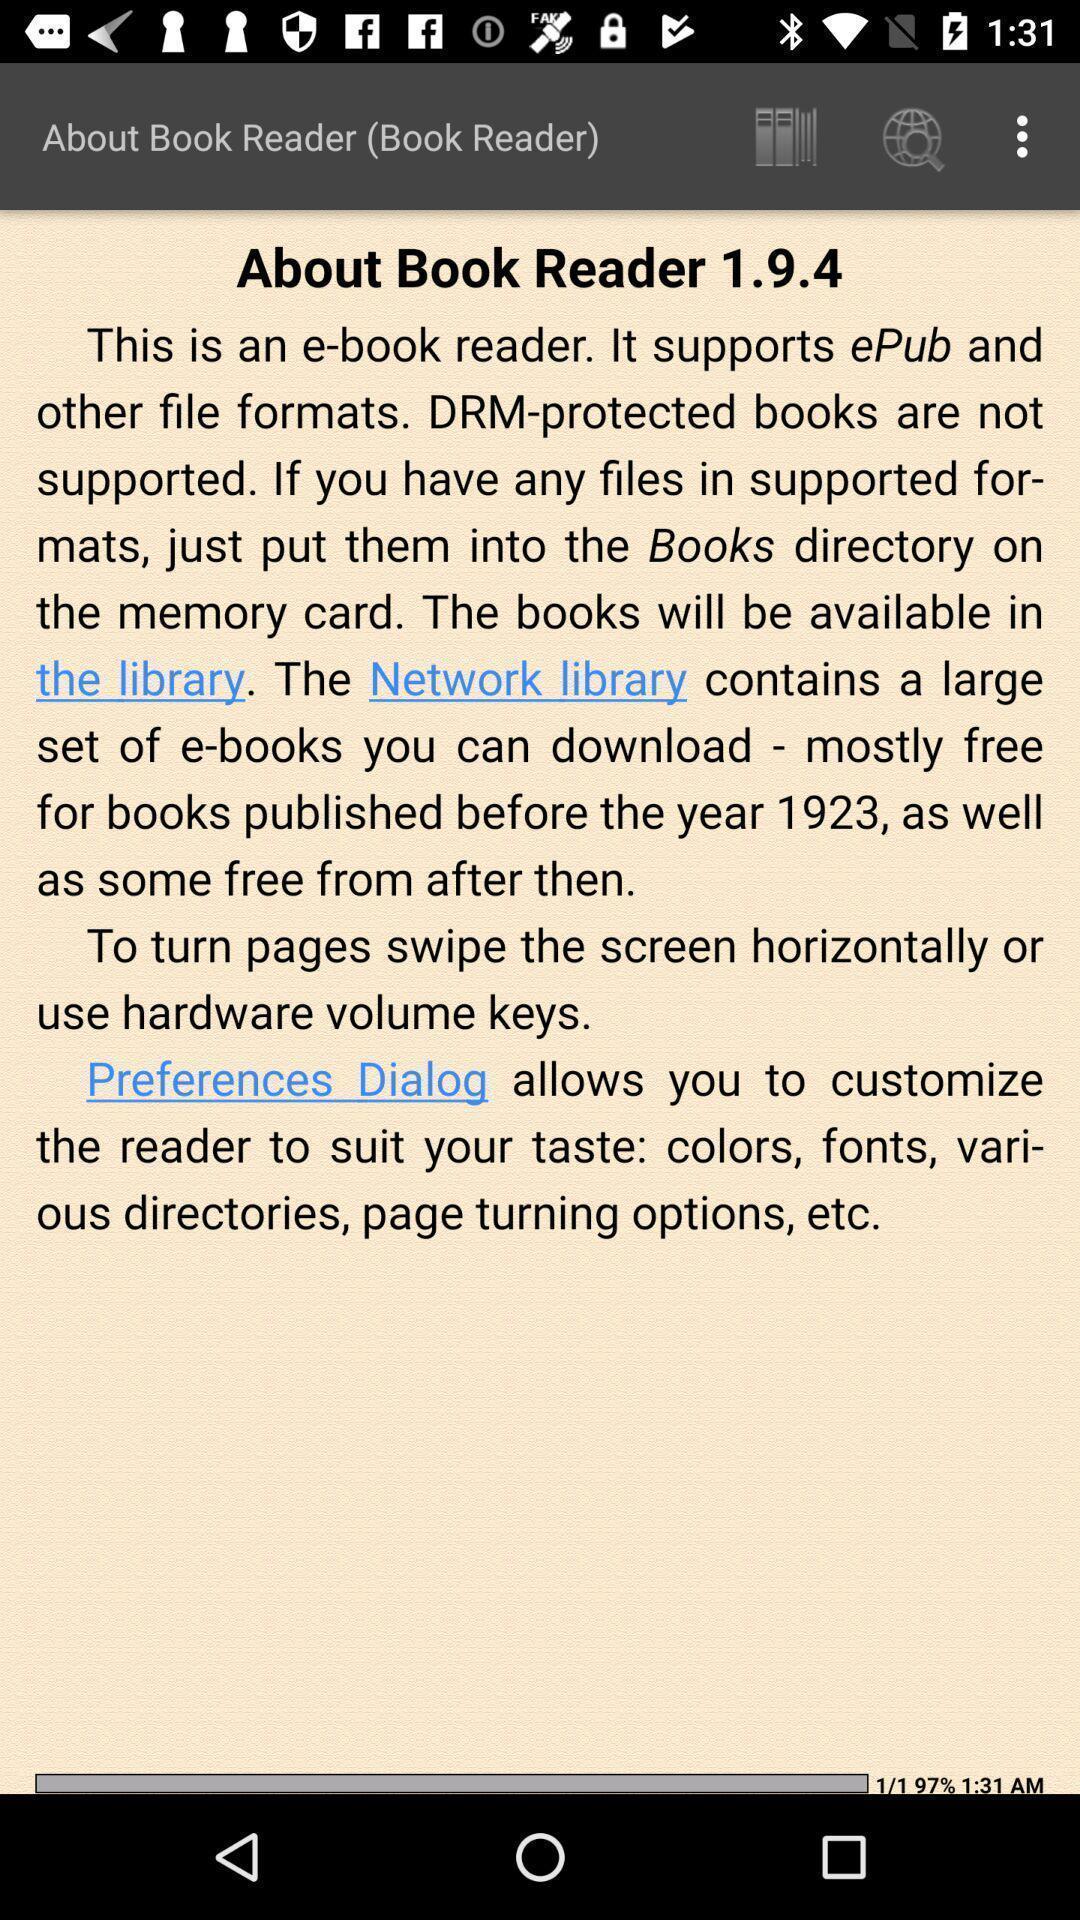Describe this image in words. Screen showing about. 